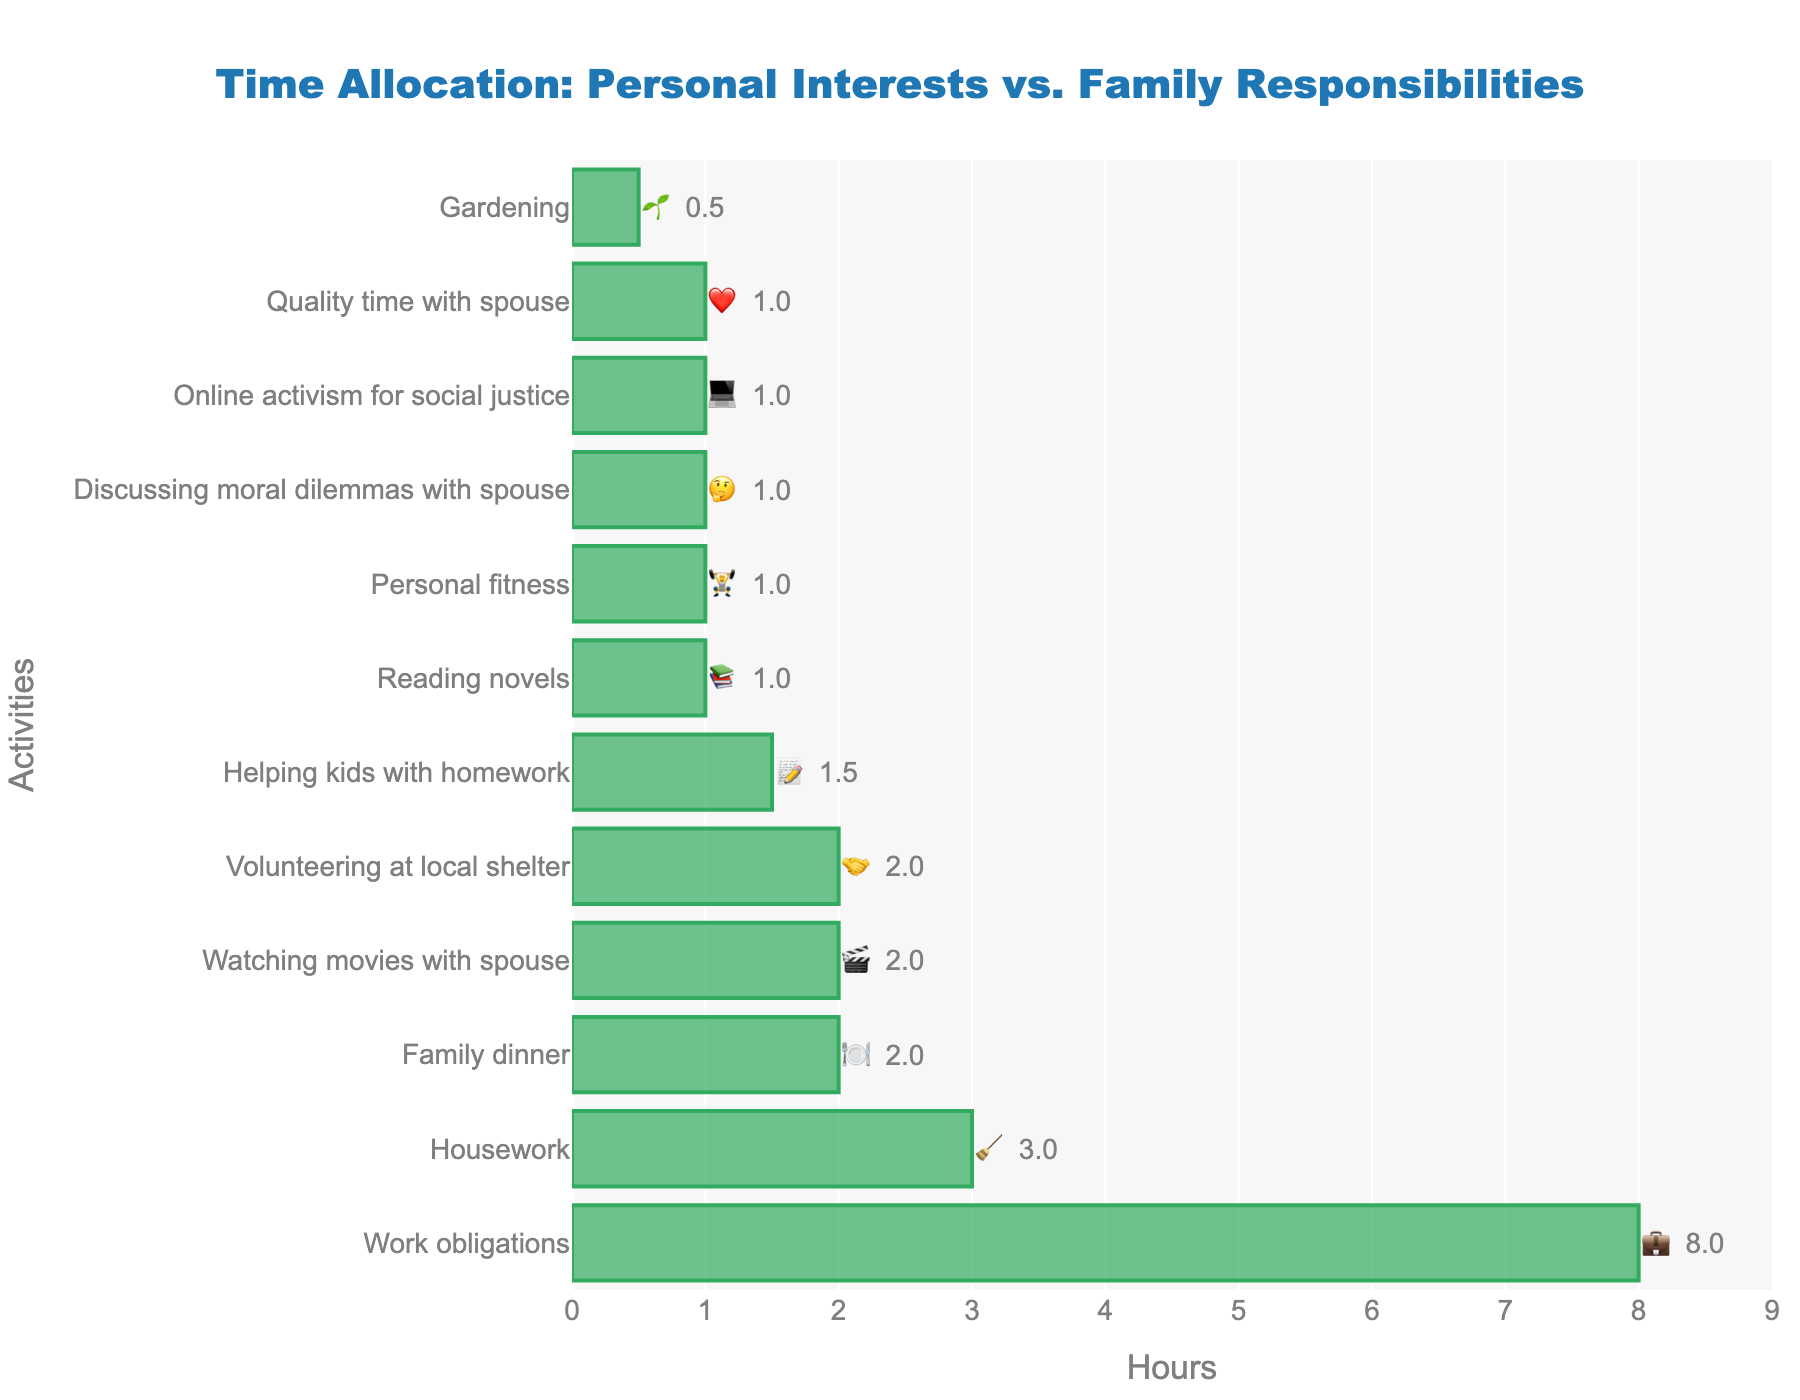what is the title of the chart? The title of the chart is typically displayed at the top of the figure and provides an overview of the chart's content. In this case, the title should indicate what the chart is about.
Answer: Time Allocation: Personal Interests vs. Family Responsibilities How many activities are displayed in total? Count the number of distinct activities listed along the y-axis of the chart.
Answer: 12 Which activity has the highest number of hours? Identify the activity with the longest bar, indicating the maximum number of hours.
Answer: Work obligations (💼) What is the sum of hours spent on family dinner and watching movies with spouse? 🍽️ + 🎬 Add the hours spent on family dinner and watching movies with spouse. These activities have 2 hours each.
Answer: 4 Which activities take up exactly 1 hour each? Check the activities that have bars corresponding to 1 hour on the x-axis.
Answer: Reading novels (📚), Personal fitness (🏋️), Discussing moral dilemmas with spouse (🤔), Quality time with spouse (❤️) Between housework and helping kids with homework, which takes more time? Compare the bars representing housework and helping kids with homework to see which one extends further along the x-axis.
Answer: Housework (🧹) What’s the total time spent on volunteering at the local shelter and online activism for social justice? 🤝 + 💻 Add the hours allocated to volunteering at the local shelter and online activism for social justice. Both activities have 2 hours and 1 hour respectively.
Answer: 3 Find the difference in hours between housework and gardening. Subtract the hours spent on gardening from the hours spent on housework.
Answer: 2.5 Calculate the average time dedicated to all activities. Sum all the hours of the activities and then divide by the number of activities to find the average. The total is 24 hours across 12 activities. Therefore, the average is 24 / 12.
Answer: 2 Which emoji represents the least amount of time spent on an activity? Identify the emoji associated with the shortest bar, indicating the smallest number of hours.
Answer: Gardening (🌱) 